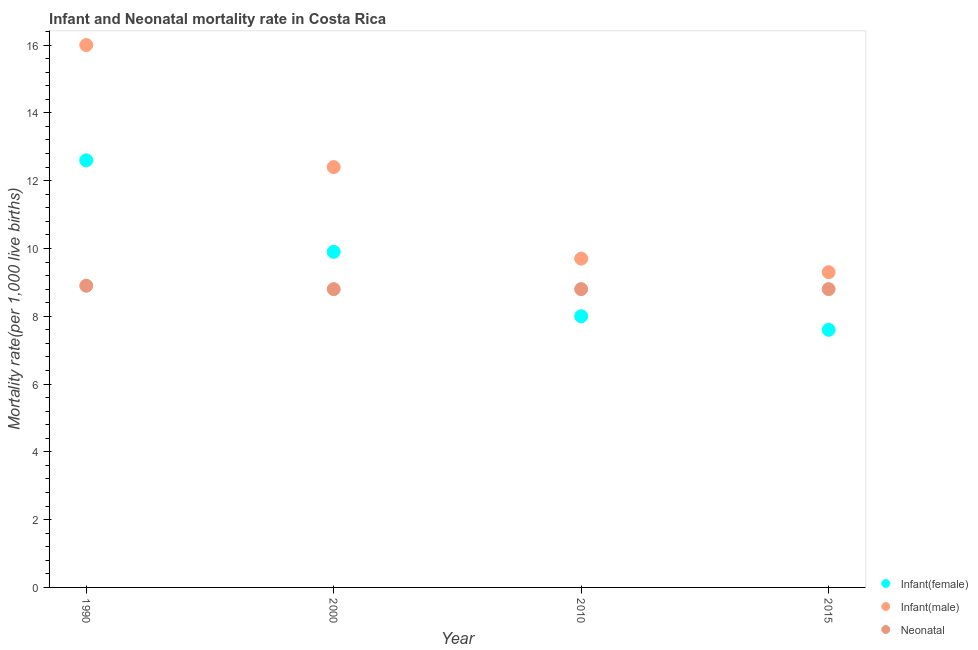Across all years, what is the maximum infant mortality rate(male)?
Make the answer very short. 16. Across all years, what is the minimum infant mortality rate(male)?
Make the answer very short. 9.3. In which year was the infant mortality rate(female) minimum?
Offer a very short reply. 2015. What is the total neonatal mortality rate in the graph?
Your response must be concise. 35.3. What is the average neonatal mortality rate per year?
Your answer should be compact. 8.83. In the year 2015, what is the difference between the infant mortality rate(female) and neonatal mortality rate?
Provide a short and direct response. -1.2. In how many years, is the infant mortality rate(female) greater than 5.6?
Offer a very short reply. 4. What is the ratio of the neonatal mortality rate in 1990 to that in 2000?
Give a very brief answer. 1.01. What is the difference between the highest and the second highest infant mortality rate(male)?
Keep it short and to the point. 3.6. What is the difference between the highest and the lowest infant mortality rate(male)?
Provide a short and direct response. 6.7. In how many years, is the neonatal mortality rate greater than the average neonatal mortality rate taken over all years?
Provide a succinct answer. 1. Is the sum of the infant mortality rate(female) in 2010 and 2015 greater than the maximum infant mortality rate(male) across all years?
Ensure brevity in your answer.  No. Is it the case that in every year, the sum of the infant mortality rate(female) and infant mortality rate(male) is greater than the neonatal mortality rate?
Ensure brevity in your answer.  Yes. Does the neonatal mortality rate monotonically increase over the years?
Offer a terse response. No. How many dotlines are there?
Give a very brief answer. 3. How many years are there in the graph?
Offer a terse response. 4. What is the difference between two consecutive major ticks on the Y-axis?
Provide a short and direct response. 2. Where does the legend appear in the graph?
Your answer should be very brief. Bottom right. How are the legend labels stacked?
Keep it short and to the point. Vertical. What is the title of the graph?
Offer a very short reply. Infant and Neonatal mortality rate in Costa Rica. What is the label or title of the X-axis?
Your response must be concise. Year. What is the label or title of the Y-axis?
Offer a terse response. Mortality rate(per 1,0 live births). What is the Mortality rate(per 1,000 live births) of Infant(female) in 1990?
Ensure brevity in your answer.  12.6. What is the Mortality rate(per 1,000 live births) in Neonatal  in 1990?
Your response must be concise. 8.9. What is the Mortality rate(per 1,000 live births) of Infant(female) in 2000?
Keep it short and to the point. 9.9. What is the Mortality rate(per 1,000 live births) of Infant(male) in 2000?
Provide a succinct answer. 12.4. What is the Mortality rate(per 1,000 live births) in Neonatal  in 2010?
Your answer should be compact. 8.8. What is the Mortality rate(per 1,000 live births) in Infant(male) in 2015?
Offer a terse response. 9.3. Across all years, what is the maximum Mortality rate(per 1,000 live births) in Infant(female)?
Make the answer very short. 12.6. Across all years, what is the maximum Mortality rate(per 1,000 live births) of Infant(male)?
Offer a very short reply. 16. Across all years, what is the maximum Mortality rate(per 1,000 live births) in Neonatal ?
Make the answer very short. 8.9. What is the total Mortality rate(per 1,000 live births) in Infant(female) in the graph?
Offer a very short reply. 38.1. What is the total Mortality rate(per 1,000 live births) of Infant(male) in the graph?
Offer a very short reply. 47.4. What is the total Mortality rate(per 1,000 live births) of Neonatal  in the graph?
Provide a short and direct response. 35.3. What is the difference between the Mortality rate(per 1,000 live births) in Infant(female) in 1990 and that in 2000?
Your response must be concise. 2.7. What is the difference between the Mortality rate(per 1,000 live births) in Neonatal  in 1990 and that in 2000?
Ensure brevity in your answer.  0.1. What is the difference between the Mortality rate(per 1,000 live births) of Neonatal  in 1990 and that in 2010?
Ensure brevity in your answer.  0.1. What is the difference between the Mortality rate(per 1,000 live births) in Infant(female) in 1990 and that in 2015?
Your answer should be compact. 5. What is the difference between the Mortality rate(per 1,000 live births) of Infant(male) in 1990 and that in 2015?
Provide a succinct answer. 6.7. What is the difference between the Mortality rate(per 1,000 live births) in Infant(female) in 2000 and that in 2010?
Your answer should be very brief. 1.9. What is the difference between the Mortality rate(per 1,000 live births) of Infant(male) in 2000 and that in 2010?
Offer a terse response. 2.7. What is the difference between the Mortality rate(per 1,000 live births) in Infant(female) in 2010 and that in 2015?
Provide a succinct answer. 0.4. What is the difference between the Mortality rate(per 1,000 live births) in Infant(male) in 2010 and that in 2015?
Make the answer very short. 0.4. What is the difference between the Mortality rate(per 1,000 live births) of Neonatal  in 2010 and that in 2015?
Offer a very short reply. 0. What is the difference between the Mortality rate(per 1,000 live births) in Infant(female) in 1990 and the Mortality rate(per 1,000 live births) in Infant(male) in 2000?
Keep it short and to the point. 0.2. What is the difference between the Mortality rate(per 1,000 live births) of Infant(female) in 1990 and the Mortality rate(per 1,000 live births) of Neonatal  in 2000?
Keep it short and to the point. 3.8. What is the difference between the Mortality rate(per 1,000 live births) of Infant(male) in 1990 and the Mortality rate(per 1,000 live births) of Neonatal  in 2000?
Offer a very short reply. 7.2. What is the difference between the Mortality rate(per 1,000 live births) of Infant(female) in 1990 and the Mortality rate(per 1,000 live births) of Neonatal  in 2010?
Ensure brevity in your answer.  3.8. What is the difference between the Mortality rate(per 1,000 live births) of Infant(male) in 1990 and the Mortality rate(per 1,000 live births) of Neonatal  in 2010?
Your answer should be compact. 7.2. What is the difference between the Mortality rate(per 1,000 live births) of Infant(female) in 1990 and the Mortality rate(per 1,000 live births) of Neonatal  in 2015?
Keep it short and to the point. 3.8. What is the difference between the Mortality rate(per 1,000 live births) of Infant(female) in 2000 and the Mortality rate(per 1,000 live births) of Infant(male) in 2010?
Give a very brief answer. 0.2. What is the difference between the Mortality rate(per 1,000 live births) of Infant(female) in 2000 and the Mortality rate(per 1,000 live births) of Neonatal  in 2010?
Your response must be concise. 1.1. What is the difference between the Mortality rate(per 1,000 live births) of Infant(male) in 2000 and the Mortality rate(per 1,000 live births) of Neonatal  in 2010?
Provide a short and direct response. 3.6. What is the difference between the Mortality rate(per 1,000 live births) of Infant(female) in 2010 and the Mortality rate(per 1,000 live births) of Neonatal  in 2015?
Provide a short and direct response. -0.8. What is the difference between the Mortality rate(per 1,000 live births) of Infant(male) in 2010 and the Mortality rate(per 1,000 live births) of Neonatal  in 2015?
Make the answer very short. 0.9. What is the average Mortality rate(per 1,000 live births) of Infant(female) per year?
Ensure brevity in your answer.  9.53. What is the average Mortality rate(per 1,000 live births) in Infant(male) per year?
Your response must be concise. 11.85. What is the average Mortality rate(per 1,000 live births) of Neonatal  per year?
Ensure brevity in your answer.  8.82. In the year 1990, what is the difference between the Mortality rate(per 1,000 live births) in Infant(female) and Mortality rate(per 1,000 live births) in Infant(male)?
Provide a short and direct response. -3.4. In the year 1990, what is the difference between the Mortality rate(per 1,000 live births) in Infant(female) and Mortality rate(per 1,000 live births) in Neonatal ?
Your response must be concise. 3.7. In the year 2000, what is the difference between the Mortality rate(per 1,000 live births) in Infant(female) and Mortality rate(per 1,000 live births) in Neonatal ?
Your answer should be compact. 1.1. In the year 2010, what is the difference between the Mortality rate(per 1,000 live births) in Infant(female) and Mortality rate(per 1,000 live births) in Infant(male)?
Your answer should be very brief. -1.7. In the year 2010, what is the difference between the Mortality rate(per 1,000 live births) in Infant(female) and Mortality rate(per 1,000 live births) in Neonatal ?
Your answer should be compact. -0.8. In the year 2010, what is the difference between the Mortality rate(per 1,000 live births) of Infant(male) and Mortality rate(per 1,000 live births) of Neonatal ?
Make the answer very short. 0.9. What is the ratio of the Mortality rate(per 1,000 live births) of Infant(female) in 1990 to that in 2000?
Give a very brief answer. 1.27. What is the ratio of the Mortality rate(per 1,000 live births) in Infant(male) in 1990 to that in 2000?
Provide a short and direct response. 1.29. What is the ratio of the Mortality rate(per 1,000 live births) in Neonatal  in 1990 to that in 2000?
Offer a very short reply. 1.01. What is the ratio of the Mortality rate(per 1,000 live births) of Infant(female) in 1990 to that in 2010?
Ensure brevity in your answer.  1.57. What is the ratio of the Mortality rate(per 1,000 live births) in Infant(male) in 1990 to that in 2010?
Your answer should be very brief. 1.65. What is the ratio of the Mortality rate(per 1,000 live births) in Neonatal  in 1990 to that in 2010?
Your answer should be very brief. 1.01. What is the ratio of the Mortality rate(per 1,000 live births) of Infant(female) in 1990 to that in 2015?
Your answer should be compact. 1.66. What is the ratio of the Mortality rate(per 1,000 live births) of Infant(male) in 1990 to that in 2015?
Give a very brief answer. 1.72. What is the ratio of the Mortality rate(per 1,000 live births) in Neonatal  in 1990 to that in 2015?
Keep it short and to the point. 1.01. What is the ratio of the Mortality rate(per 1,000 live births) in Infant(female) in 2000 to that in 2010?
Keep it short and to the point. 1.24. What is the ratio of the Mortality rate(per 1,000 live births) in Infant(male) in 2000 to that in 2010?
Your answer should be compact. 1.28. What is the ratio of the Mortality rate(per 1,000 live births) in Infant(female) in 2000 to that in 2015?
Make the answer very short. 1.3. What is the ratio of the Mortality rate(per 1,000 live births) of Neonatal  in 2000 to that in 2015?
Keep it short and to the point. 1. What is the ratio of the Mortality rate(per 1,000 live births) in Infant(female) in 2010 to that in 2015?
Provide a succinct answer. 1.05. What is the ratio of the Mortality rate(per 1,000 live births) of Infant(male) in 2010 to that in 2015?
Your response must be concise. 1.04. What is the ratio of the Mortality rate(per 1,000 live births) in Neonatal  in 2010 to that in 2015?
Give a very brief answer. 1. What is the difference between the highest and the second highest Mortality rate(per 1,000 live births) in Neonatal ?
Your answer should be compact. 0.1. What is the difference between the highest and the lowest Mortality rate(per 1,000 live births) in Infant(male)?
Give a very brief answer. 6.7. 